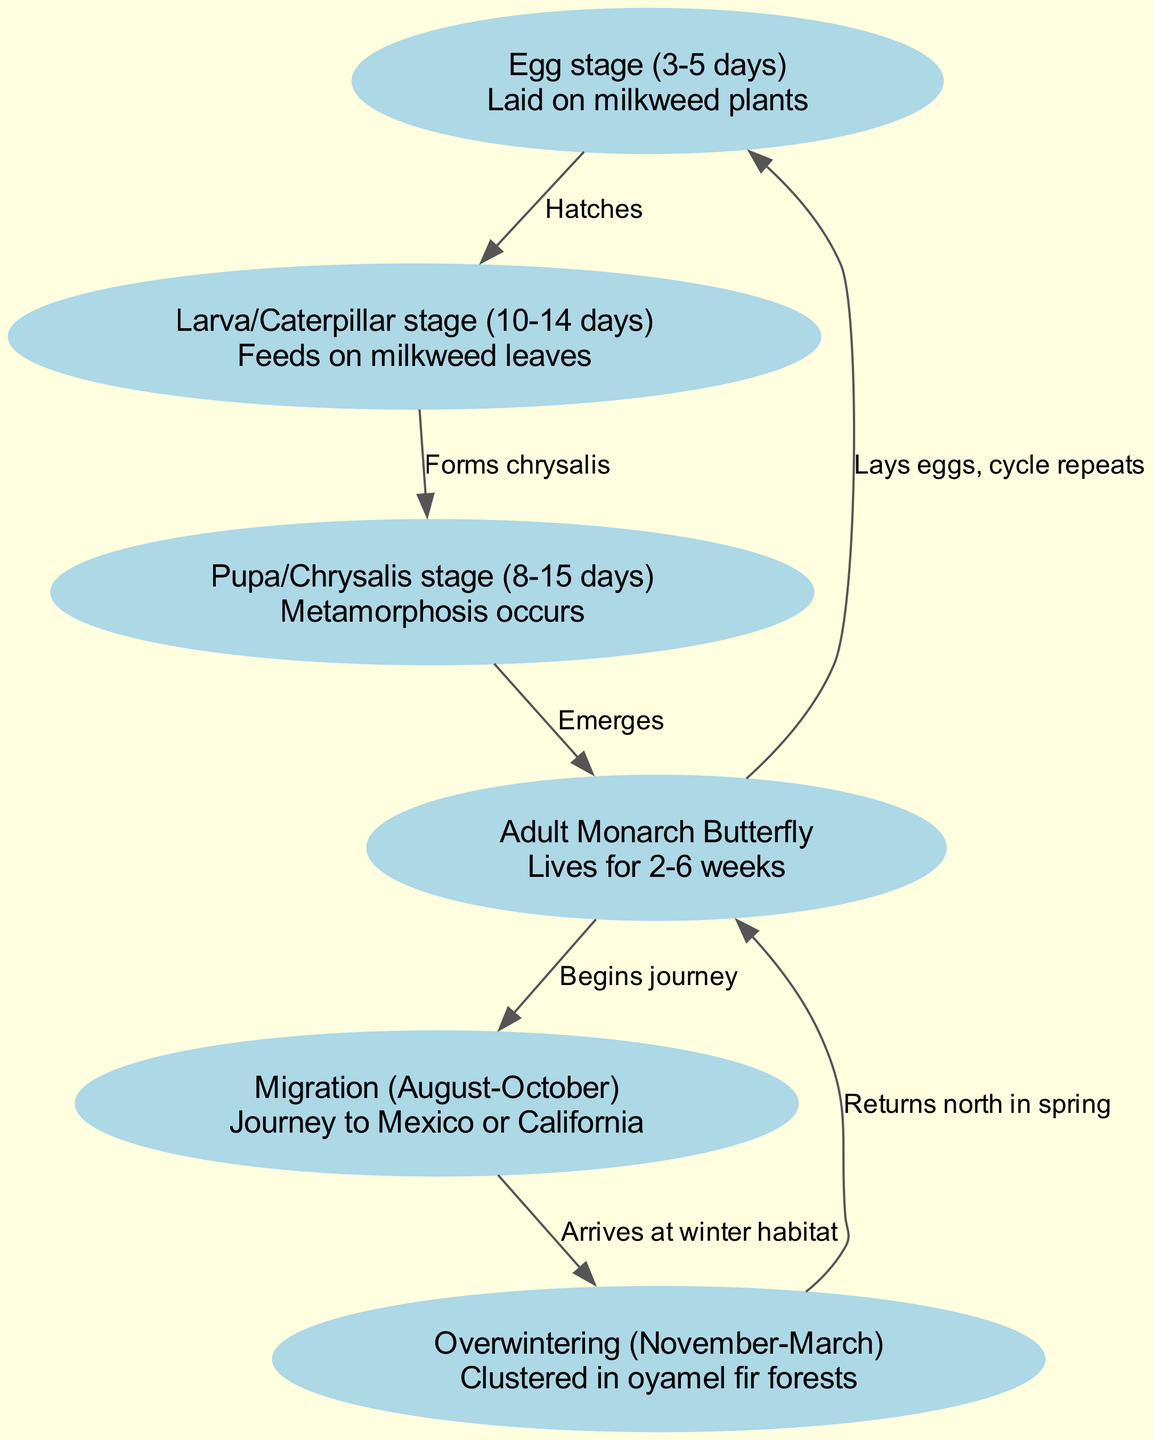What's the lifespan of an adult monarch butterfly? The diagram states that the adult monarch butterfly lives for 2-6 weeks, which is specifically mentioned in the description of the "Adult Monarch Butterfly" node.
Answer: 2-6 weeks What happens after the larva stage? The diagram indicates that after the larva (caterpillar) stage, it "Forms chrysalis" leading to the next node "Pupa." This is indicated by the edge connecting the larva and pupa nodes labeled "Forms chrysalis."
Answer: Forms chrysalis How long does the pupa (chrysalis) stage last? In the diagram, the "Pupa/Chrysalis stage" node specifies it lasts between 8 and 15 days, as mentioned in its description.
Answer: 8-15 days What is the beginning of the migration phase for monarch butterflies? The edge from the "Adult Monarch Butterfly" node to the "Migration" node is labeled "Begins journey," indicating the start of the migration after reaching the adult stage.
Answer: Begins journey What environment do monarchs cluster in during overwintering? The description under the "Overwintering" node states they cluster in "oyamel fir forests," providing specific habitat information for this phase.
Answer: oyamel fir forests How many main stages are there in the life cycle of a monarch butterfly? By counting the nodes in the diagram, including egg, larva, pupa, adult, migration, and overwintering, we find a total of 6 stages in the life cycle.
Answer: 6 What is the last node in the cycle leading back to the egg stage? The diagram shows that the final relationship leads from the "Adult Monarch Butterfly" node back to the "Egg stage," completed by the edge labeled "Lays eggs, cycle repeats." This indicates the cycle restarts.
Answer: Egg stage What time of year do monarch butterflies migrate? The description in the "Migration" node indicates that this phase occurs from August to October, providing the relevant seasonal information.
Answer: August-October 